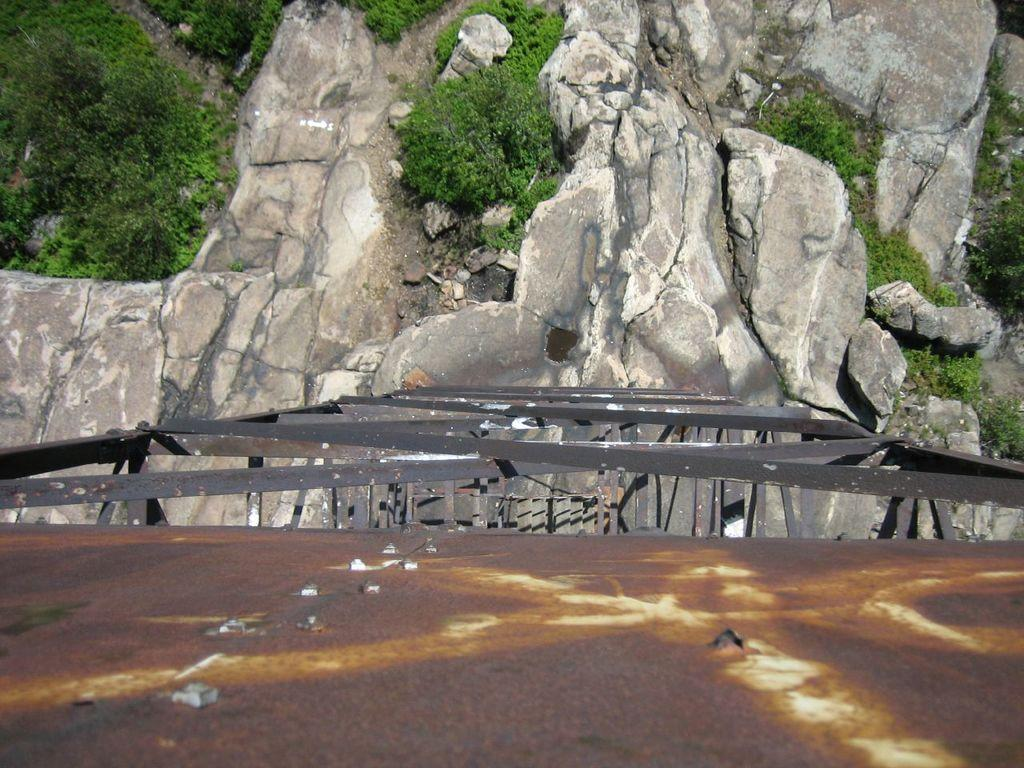What type of surface is present in the image? There is a metallic surface in the image. What objects are made of metal in the image? There are metal rods in the image. What type of natural formations can be seen in the image? Rock hills are visible in the image. What type of vegetation is present in the image? There are trees in the image. How many bananas are hanging from the trees in the image? There are no bananas present in the image; only trees are visible. 